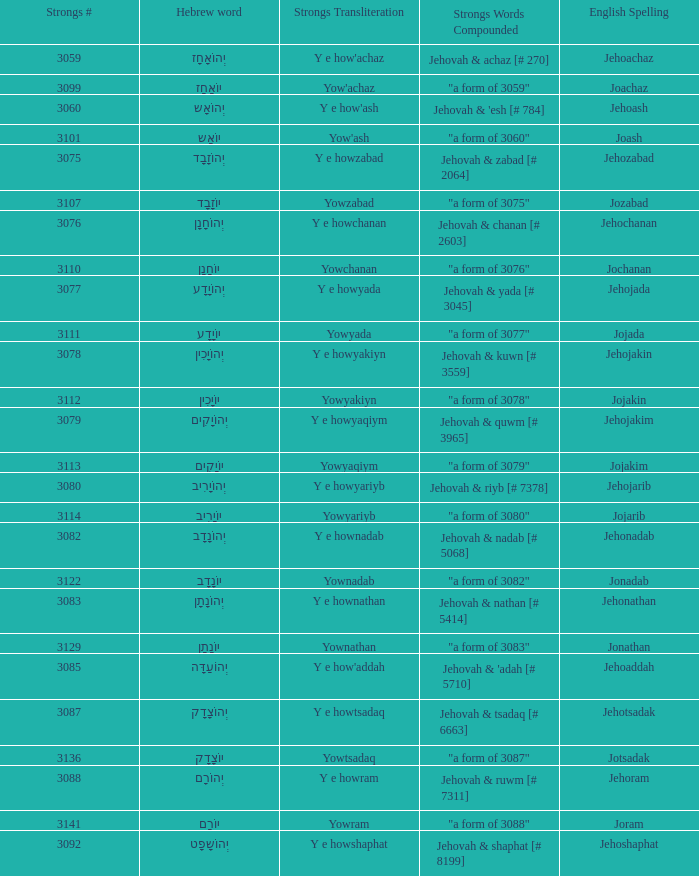Write the full table. {'header': ['Strongs #', 'Hebrew word', 'Strongs Transliteration', 'Strongs Words Compounded', 'English Spelling'], 'rows': [['3059', 'יְהוֹאָחָז', "Y e how'achaz", 'Jehovah & achaz [# 270]', 'Jehoachaz'], ['3099', 'יוֹאָחָז', "Yow'achaz", '"a form of 3059"', 'Joachaz'], ['3060', 'יְהוֹאָש', "Y e how'ash", "Jehovah & 'esh [# 784]", 'Jehoash'], ['3101', 'יוֹאָש', "Yow'ash", '"a form of 3060"', 'Joash'], ['3075', 'יְהוֹזָבָד', 'Y e howzabad', 'Jehovah & zabad [# 2064]', 'Jehozabad'], ['3107', 'יוֹזָבָד', 'Yowzabad', '"a form of 3075"', 'Jozabad'], ['3076', 'יְהוֹחָנָן', 'Y e howchanan', 'Jehovah & chanan [# 2603]', 'Jehochanan'], ['3110', 'יוֹחָנָן', 'Yowchanan', '"a form of 3076"', 'Jochanan'], ['3077', 'יְהוֹיָדָע', 'Y e howyada', 'Jehovah & yada [# 3045]', 'Jehojada'], ['3111', 'יוֹיָדָע', 'Yowyada', '"a form of 3077"', 'Jojada'], ['3078', 'יְהוֹיָכִין', 'Y e howyakiyn', 'Jehovah & kuwn [# 3559]', 'Jehojakin'], ['3112', 'יוֹיָכִין', 'Yowyakiyn', '"a form of 3078"', 'Jojakin'], ['3079', 'יְהוֹיָקִים', 'Y e howyaqiym', 'Jehovah & quwm [# 3965]', 'Jehojakim'], ['3113', 'יוֹיָקִים', 'Yowyaqiym', '"a form of 3079"', 'Jojakim'], ['3080', 'יְהוֹיָרִיב', 'Y e howyariyb', 'Jehovah & riyb [# 7378]', 'Jehojarib'], ['3114', 'יוֹיָרִיב', 'Yowyariyb', '"a form of 3080"', 'Jojarib'], ['3082', 'יְהוֹנָדָב', 'Y e hownadab', 'Jehovah & nadab [# 5068]', 'Jehonadab'], ['3122', 'יוֹנָדָב', 'Yownadab', '"a form of 3082"', 'Jonadab'], ['3083', 'יְהוֹנָתָן', 'Y e hownathan', 'Jehovah & nathan [# 5414]', 'Jehonathan'], ['3129', 'יוֹנָתָן', 'Yownathan', '"a form of 3083"', 'Jonathan'], ['3085', 'יְהוֹעַדָּה', "Y e how'addah", "Jehovah & 'adah [# 5710]", 'Jehoaddah'], ['3087', 'יְהוֹצָדָק', 'Y e howtsadaq', 'Jehovah & tsadaq [# 6663]', 'Jehotsadak'], ['3136', 'יוֹצָדָק', 'Yowtsadaq', '"a form of 3087"', 'Jotsadak'], ['3088', 'יְהוֹרָם', 'Y e howram', 'Jehovah & ruwm [# 7311]', 'Jehoram'], ['3141', 'יוֹרָם', 'Yowram', '"a form of 3088"', 'Joram'], ['3092', 'יְהוֹשָפָט', 'Y e howshaphat', 'Jehovah & shaphat [# 8199]', 'Jehoshaphat']]} In the strong's system, what is the number of transliterations for the english spelling of jehojakin? 1.0. 